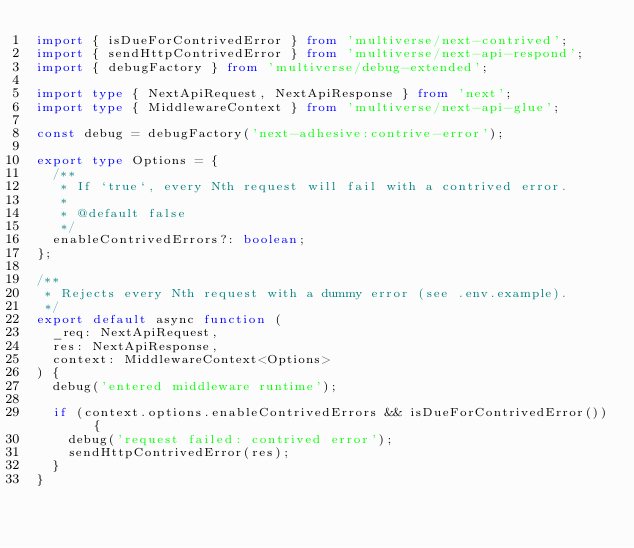Convert code to text. <code><loc_0><loc_0><loc_500><loc_500><_TypeScript_>import { isDueForContrivedError } from 'multiverse/next-contrived';
import { sendHttpContrivedError } from 'multiverse/next-api-respond';
import { debugFactory } from 'multiverse/debug-extended';

import type { NextApiRequest, NextApiResponse } from 'next';
import type { MiddlewareContext } from 'multiverse/next-api-glue';

const debug = debugFactory('next-adhesive:contrive-error');

export type Options = {
  /**
   * If `true`, every Nth request will fail with a contrived error.
   *
   * @default false
   */
  enableContrivedErrors?: boolean;
};

/**
 * Rejects every Nth request with a dummy error (see .env.example).
 */
export default async function (
  _req: NextApiRequest,
  res: NextApiResponse,
  context: MiddlewareContext<Options>
) {
  debug('entered middleware runtime');

  if (context.options.enableContrivedErrors && isDueForContrivedError()) {
    debug('request failed: contrived error');
    sendHttpContrivedError(res);
  }
}
</code> 